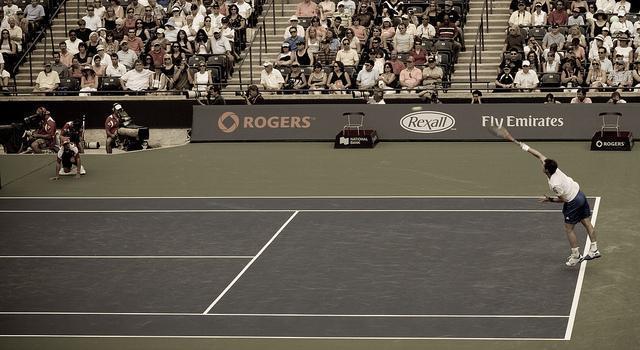What does Fly Emirates provide to the game?
Make your selection and explain in format: 'Answer: answer
Rationale: rationale.'
Options: Drink, food, sponsor, transportation. Answer: sponsor.
Rationale: Sponsors are generally displayed on the boards of tennis games. 